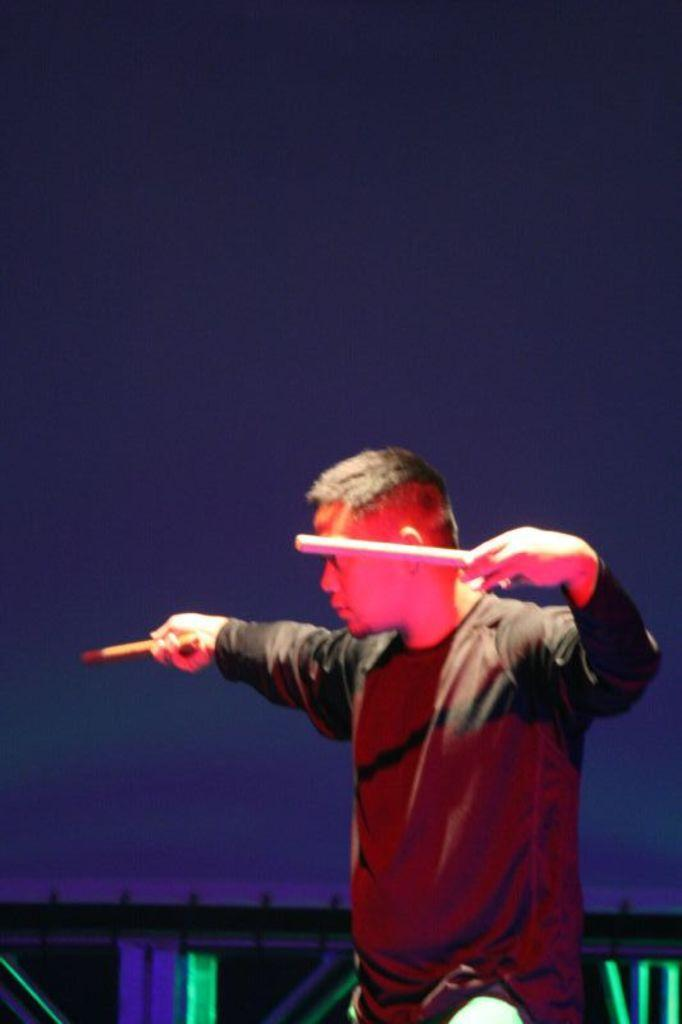What is the main subject of the image? There is a man in the image. What is the man doing in the image? The man is holding sticks with both hands. Can you describe the lighting in the image? There is there a specific color? How many horses are present in the image? There are no horses present in the image. What type of wind can be seen blowing in the image? There is no wind or blowing element present in the image. 